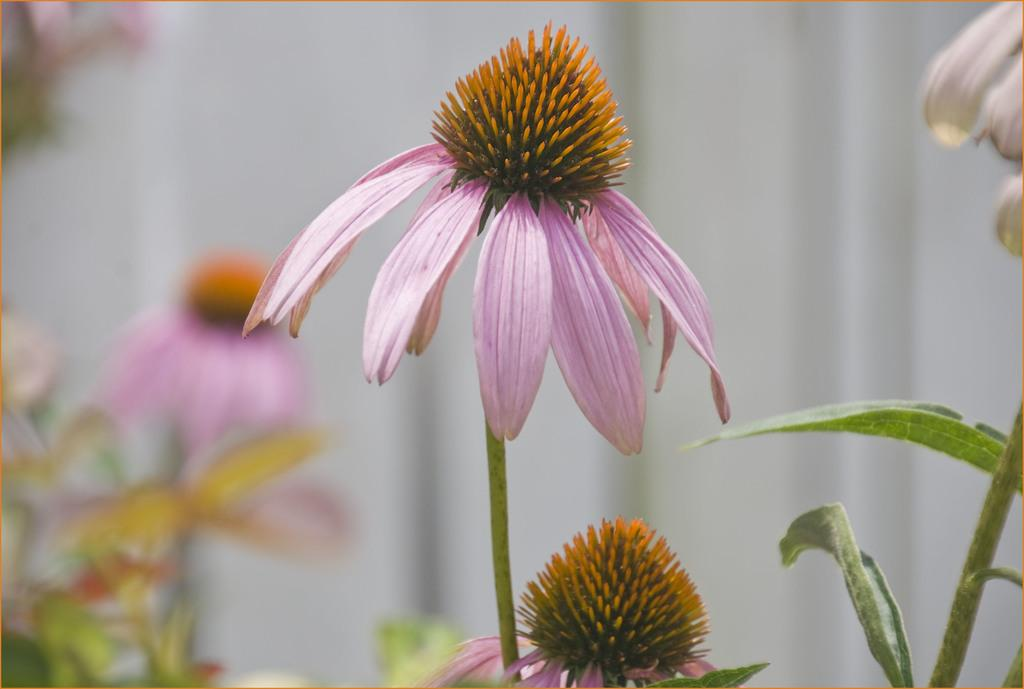What type of flora is present in the image? There are flowers in the image. What color are the flowers? The flowers are pink in color. Where is the chess game being played in the image? There is no chess game present in the image; it only features flowers. What type of hall is visible in the image? There is no hall present in the image; it only features flowers. 